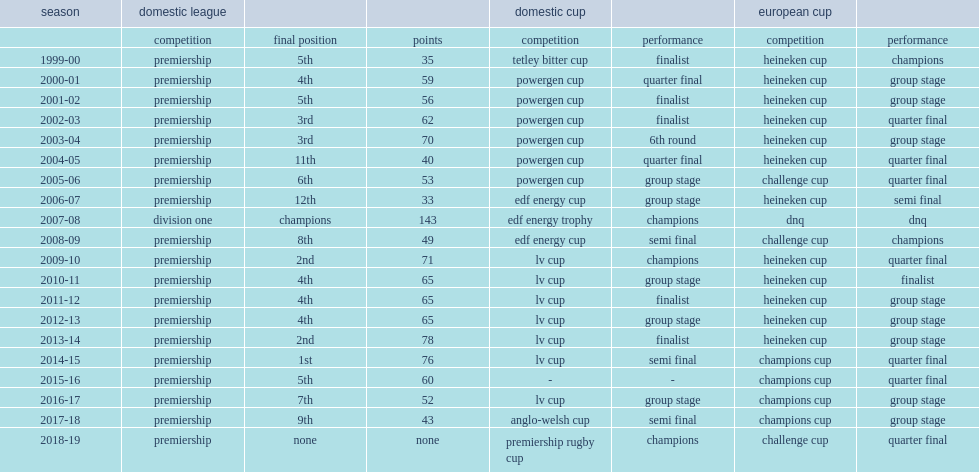What competitons did the northampton saints win ? Edf energy trophy premiership rugby cup. 